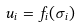Convert formula to latex. <formula><loc_0><loc_0><loc_500><loc_500>u _ { i } = f _ { i } ( \sigma _ { i } )</formula> 